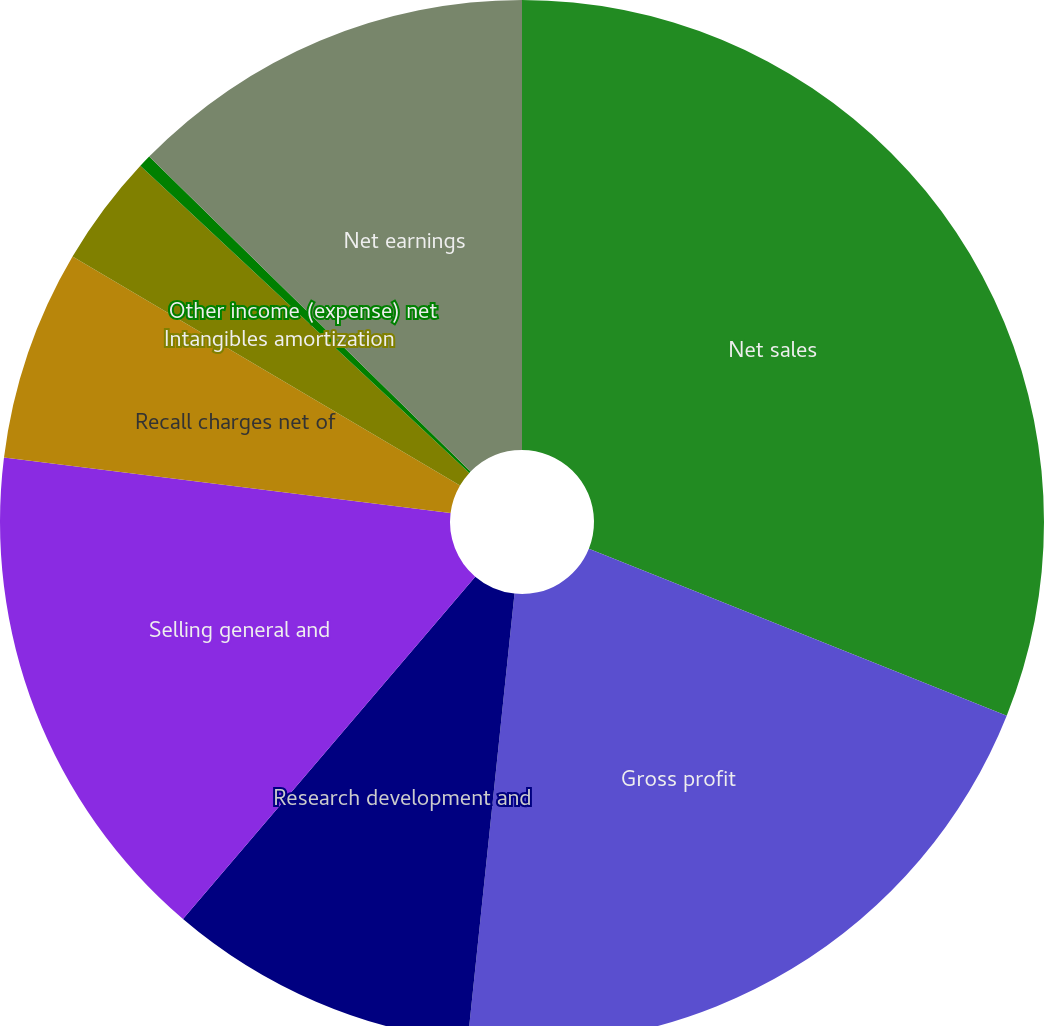<chart> <loc_0><loc_0><loc_500><loc_500><pie_chart><fcel>Net sales<fcel>Gross profit<fcel>Research development and<fcel>Selling general and<fcel>Recall charges net of<fcel>Intangibles amortization<fcel>Other income (expense) net<fcel>Net earnings<nl><fcel>31.05%<fcel>20.61%<fcel>9.59%<fcel>15.72%<fcel>6.52%<fcel>3.46%<fcel>0.39%<fcel>12.66%<nl></chart> 